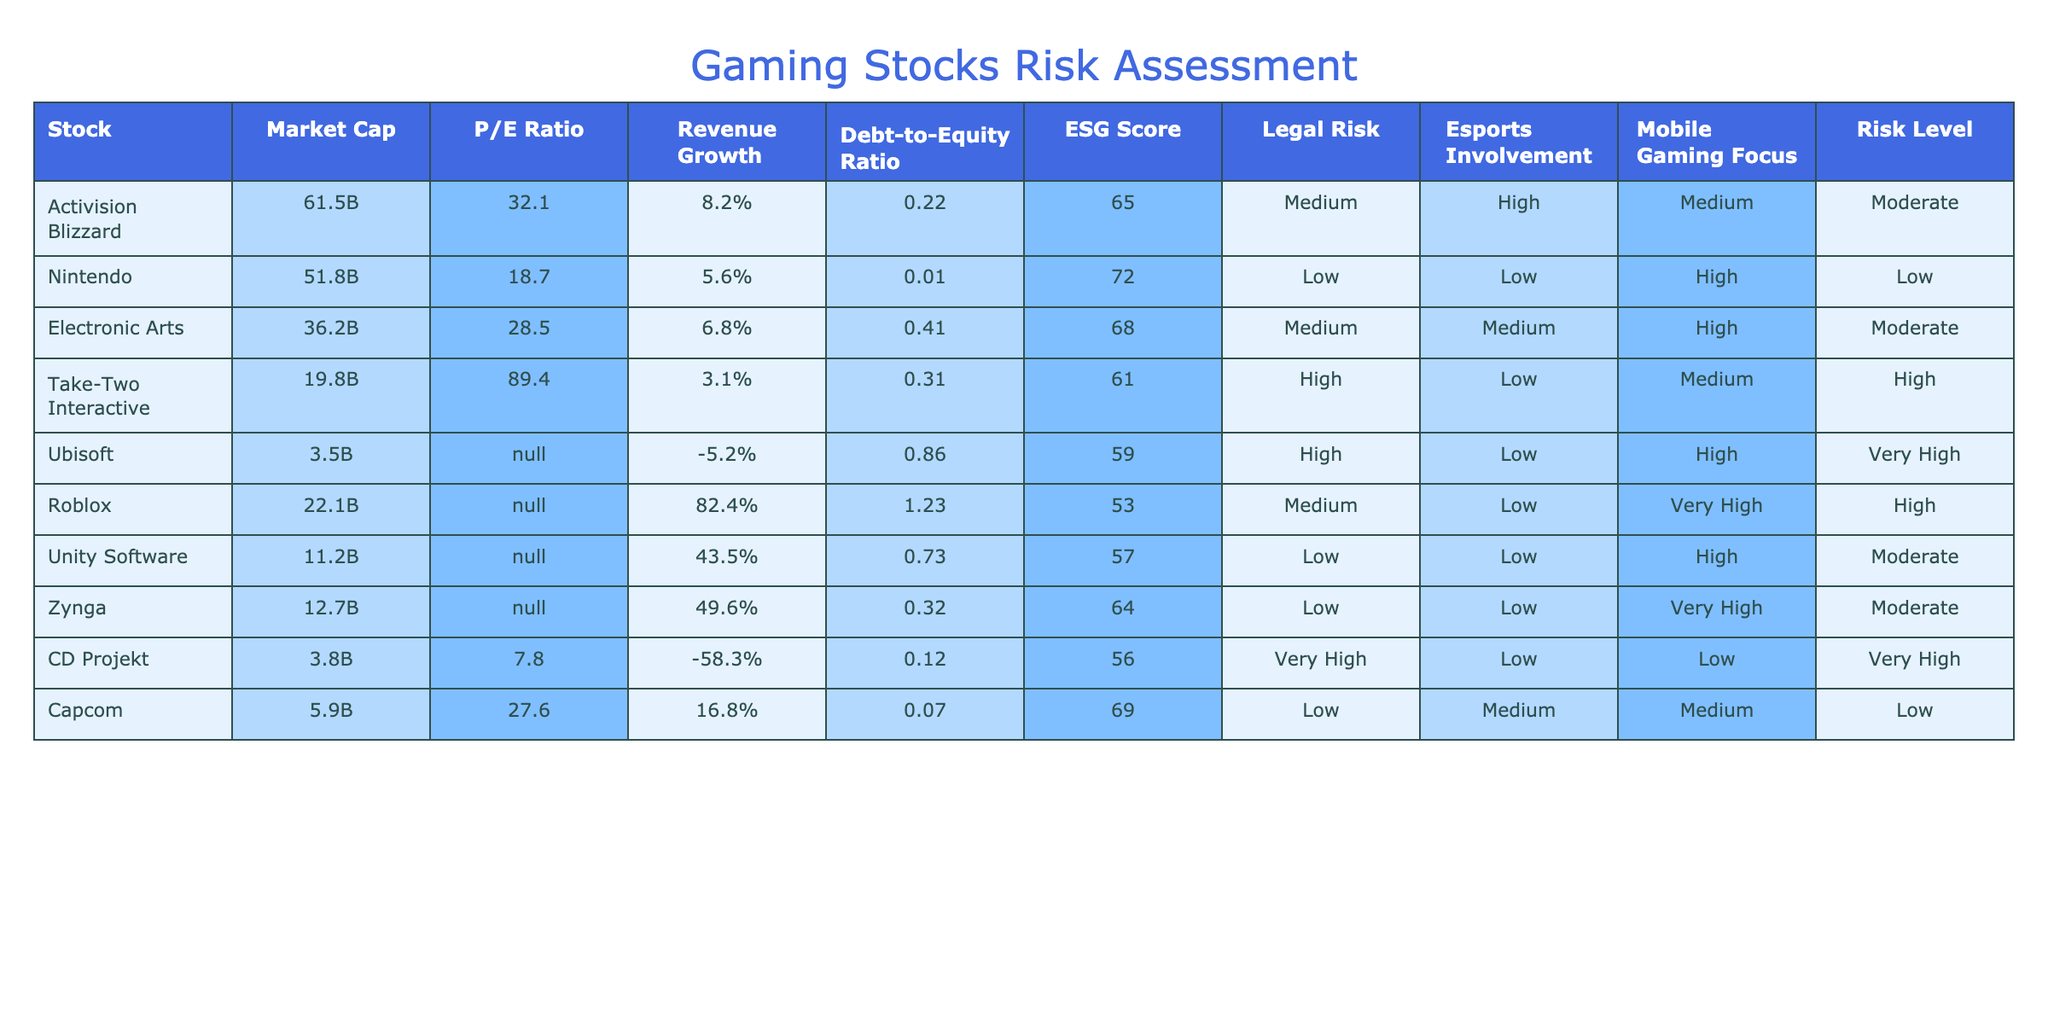What is the market cap of Electronic Arts? The table shows that the market cap of Electronic Arts is listed as 36.2B.
Answer: 36.2B Which company has the highest P/E ratio? Looking through the P/E ratio column, Take-Two Interactive is noted to have the highest P/E ratio at 89.4.
Answer: Take-Two Interactive Is the debt-to-equity ratio of Nintendo greater than 0? In the debt-to-equity ratio column, Nintendo shows a value of 0.01, which is indeed greater than 0.
Answer: Yes Calculate the average revenue growth for all companies listed. The revenue growth values to consider are: 8.2% (Activision Blizzard), 5.6% (Nintendo), 6.8% (Electronic Arts), 3.1% (Take-Two Interactive), -5.2% (Ubisoft), 82.4% (Roblox), 43.5% (Unity Software), 49.6% (Zynga), -58.3% (CD Projekt), and 16.8% (Capcom). Adding those values gives 8.2 + 5.6 + 6.8 + 3.1 - 5.2 + 82.4 + 43.5 + 49.6 - 58.3 + 16.8 =  12.5%. Dividing by the number of companies (10), the average revenue growth is 1.25%.
Answer: 1.25% Are companies with a low ESG score more likely to have high legal risk? Upon examining the ESG score and legal risk columns, we see that 5 companies with low ESG scores (Nintendo, Unity Software, Zynga, Capcom) are categorized as having low or medium legal risk, while companies with high legal risk have both high and medium ESG scores. This suggests no direct correlation.
Answer: No 